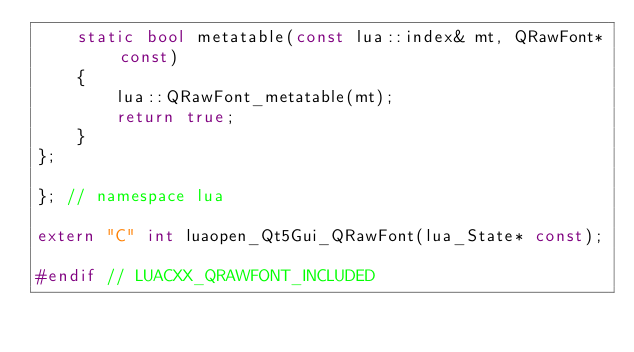<code> <loc_0><loc_0><loc_500><loc_500><_C++_>    static bool metatable(const lua::index& mt, QRawFont* const)
    {
        lua::QRawFont_metatable(mt);
        return true;
    }
};

}; // namespace lua

extern "C" int luaopen_Qt5Gui_QRawFont(lua_State* const);

#endif // LUACXX_QRAWFONT_INCLUDED
</code> 